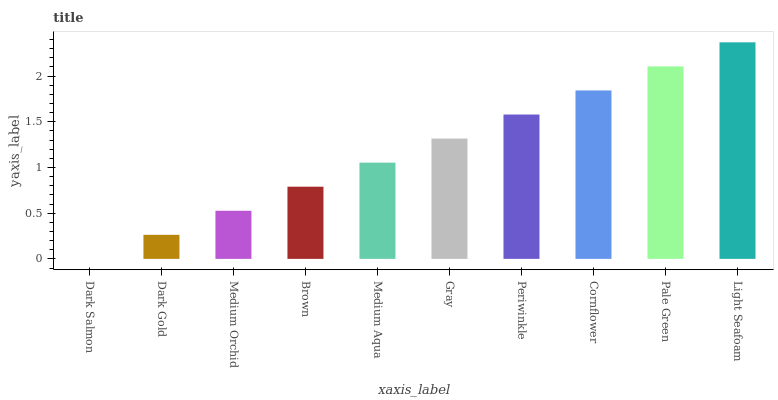Is Dark Salmon the minimum?
Answer yes or no. Yes. Is Light Seafoam the maximum?
Answer yes or no. Yes. Is Dark Gold the minimum?
Answer yes or no. No. Is Dark Gold the maximum?
Answer yes or no. No. Is Dark Gold greater than Dark Salmon?
Answer yes or no. Yes. Is Dark Salmon less than Dark Gold?
Answer yes or no. Yes. Is Dark Salmon greater than Dark Gold?
Answer yes or no. No. Is Dark Gold less than Dark Salmon?
Answer yes or no. No. Is Gray the high median?
Answer yes or no. Yes. Is Medium Aqua the low median?
Answer yes or no. Yes. Is Dark Gold the high median?
Answer yes or no. No. Is Cornflower the low median?
Answer yes or no. No. 